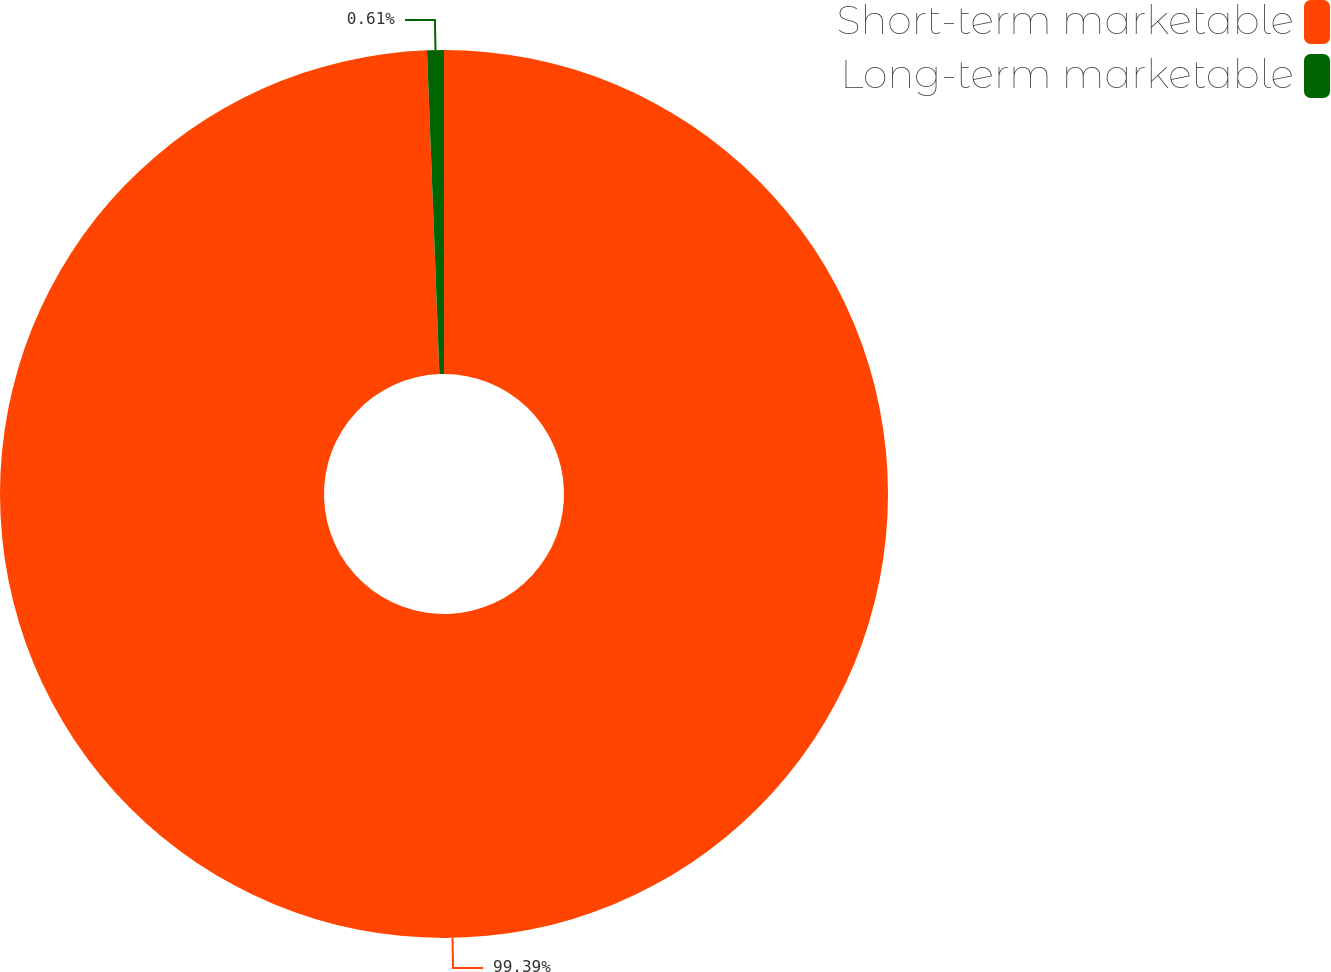<chart> <loc_0><loc_0><loc_500><loc_500><pie_chart><fcel>Short-term marketable<fcel>Long-term marketable<nl><fcel>99.39%<fcel>0.61%<nl></chart> 